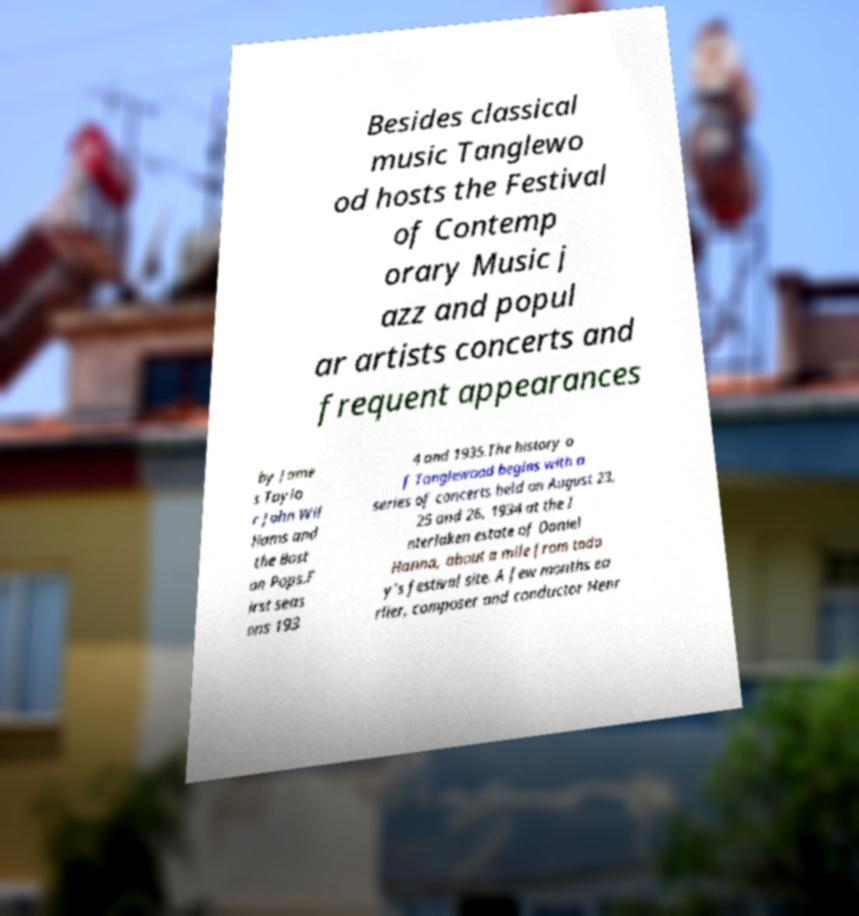Could you extract and type out the text from this image? Besides classical music Tanglewo od hosts the Festival of Contemp orary Music j azz and popul ar artists concerts and frequent appearances by Jame s Taylo r John Wil liams and the Bost on Pops.F irst seas ons 193 4 and 1935.The history o f Tanglewood begins with a series of concerts held on August 23, 25 and 26, 1934 at the I nterlaken estate of Daniel Hanna, about a mile from toda y’s festival site. A few months ea rlier, composer and conductor Henr 